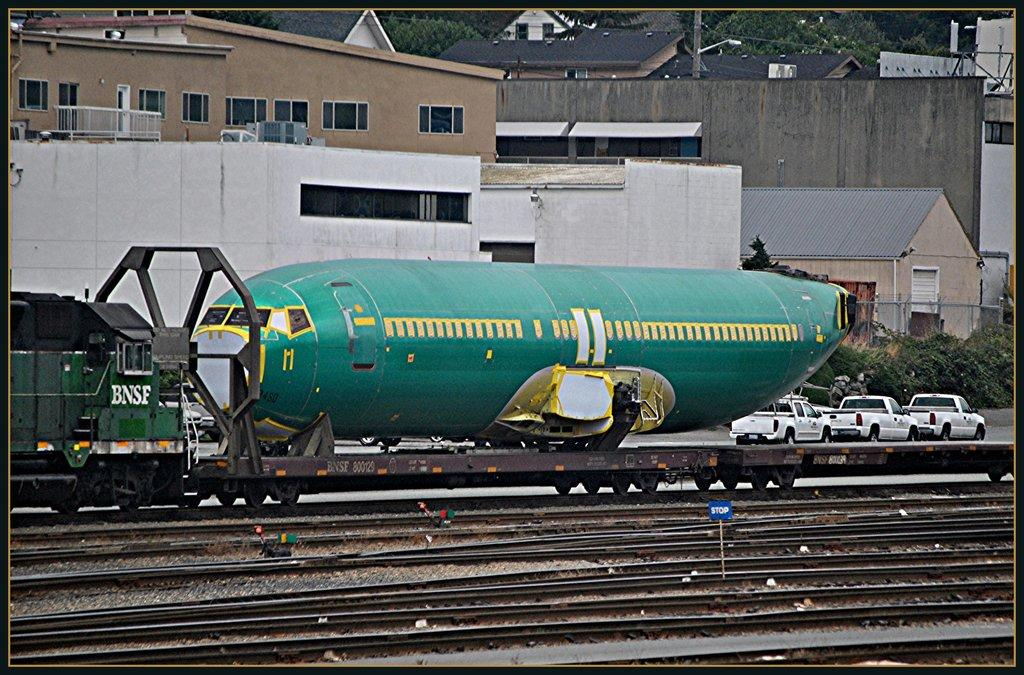<image>
Give a short and clear explanation of the subsequent image. A body of a passenger jet is on the top of BNSF cargo rail behind the blue stop sign. 